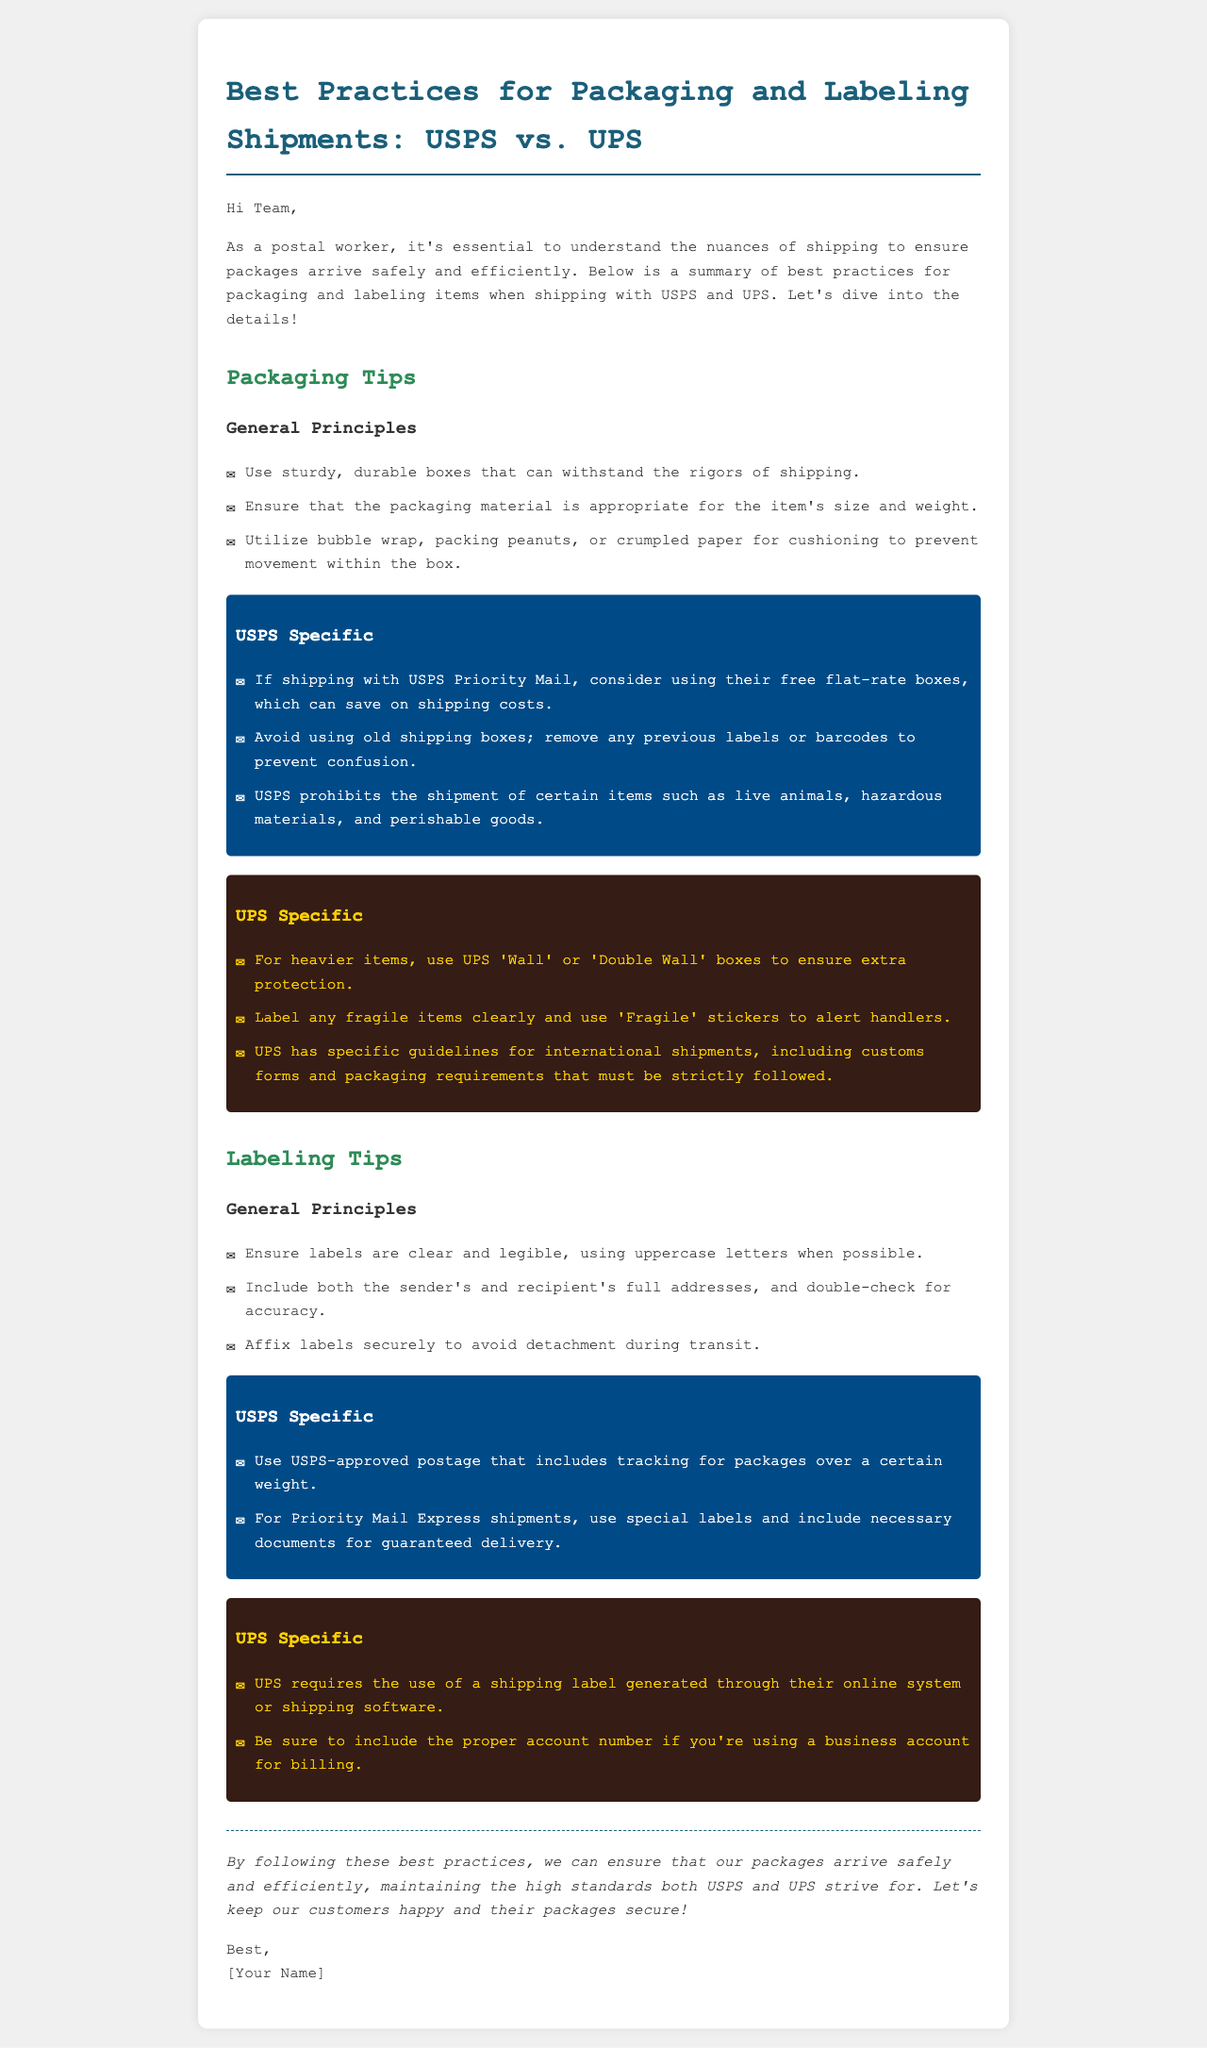What is the title of the document? The title is stated at the top of the document and summarizes the main content about shipping practices.
Answer: Best Practices for Packaging and Labeling Shipments: USPS vs. UPS What type of boxes should USPS Priority Mail users consider using? The document mentions specific types of boxes suggested for USPS Priority Mail to help with costs.
Answer: Free flat-rate boxes What type of packaging does UPS recommend for heavier items? UPS provides specific suggestions for strengthening the packaging of heavy items to prevent damage during shipping.
Answer: Wall or Double Wall boxes Which materials does USPS prohibit for shipment? The document lists prohibited items specific to USPS shipping practices.
Answer: Live animals, hazardous materials, perishable goods What is a labeling requirement for UPS? The document specifies what type of labels UPS requires for shipping, especially for business accounts.
Answer: Shipping label generated through their online system What must be included in USPS Priority Mail Express shipments? This is specified as a requirement for ensuring the purpose of special shipments is fulfilled.
Answer: Special labels and necessary documents Who is the intended audience for this email? The email opens with a greeting specifically directed to a particular group, implying its readership.
Answer: Team What is the general guideline for label legibility? The document mentions an important guideline that enhances label readability during shipping.
Answer: Use uppercase letters What does the conclusion emphasize? The conclusion summarizes the document's main aim regarding packages and customer satisfaction.
Answer: Arrive safely and efficiently 